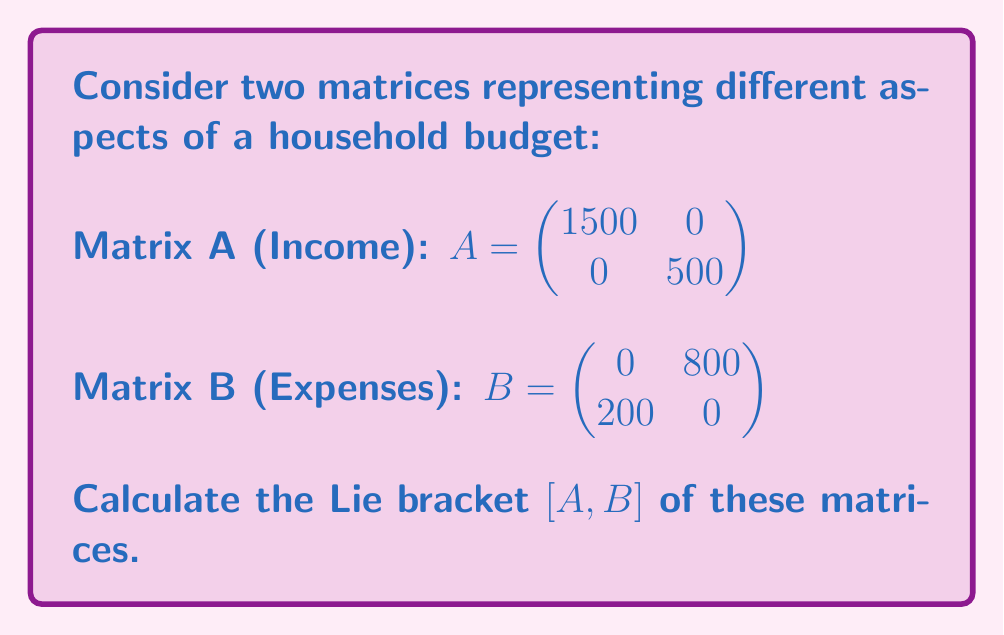Can you solve this math problem? To solve this problem, we need to follow these steps:

1) Recall that the Lie bracket of two matrices A and B is defined as:

   $[A,B] = AB - BA$

2) First, let's calculate AB:
   
   $AB = \begin{pmatrix} 1500 & 0 \\ 0 & 500 \end{pmatrix} \begin{pmatrix} 0 & 800 \\ 200 & 0 \end{pmatrix}$
   
   $= \begin{pmatrix} (1500 \cdot 0 + 0 \cdot 200) & (1500 \cdot 800 + 0 \cdot 0) \\ (0 \cdot 0 + 500 \cdot 200) & (0 \cdot 800 + 500 \cdot 0) \end{pmatrix}$
   
   $= \begin{pmatrix} 0 & 1200000 \\ 100000 & 0 \end{pmatrix}$

3) Now, let's calculate BA:
   
   $BA = \begin{pmatrix} 0 & 800 \\ 200 & 0 \end{pmatrix} \begin{pmatrix} 1500 & 0 \\ 0 & 500 \end{pmatrix}$
   
   $= \begin{pmatrix} (0 \cdot 1500 + 800 \cdot 0) & (0 \cdot 0 + 800 \cdot 500) \\ (200 \cdot 1500 + 0 \cdot 0) & (200 \cdot 0 + 0 \cdot 500) \end{pmatrix}$
   
   $= \begin{pmatrix} 0 & 400000 \\ 300000 & 0 \end{pmatrix}$

4) Finally, we can calculate $[A,B] = AB - BA$:

   $[A,B] = \begin{pmatrix} 0 & 1200000 \\ 100000 & 0 \end{pmatrix} - \begin{pmatrix} 0 & 400000 \\ 300000 & 0 \end{pmatrix}$
   
   $= \begin{pmatrix} 0 - 0 & 1200000 - 400000 \\ 100000 - 300000 & 0 - 0 \end{pmatrix}$
   
   $= \begin{pmatrix} 0 & 800000 \\ -200000 & 0 \end{pmatrix}$

This result represents the "mismatch" between income and expenses in the household budget.
Answer: $[A,B] = \begin{pmatrix} 0 & 800000 \\ -200000 & 0 \end{pmatrix}$ 